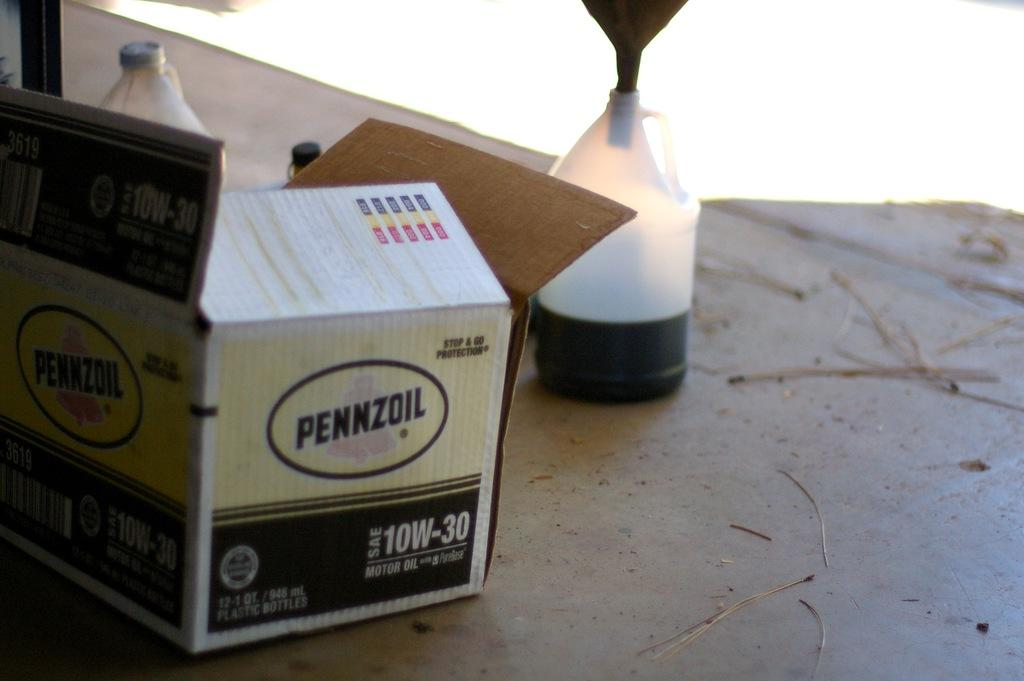<image>
Relay a brief, clear account of the picture shown. pennzoil box that contains 10w 30 oil that is being poured in a jug 